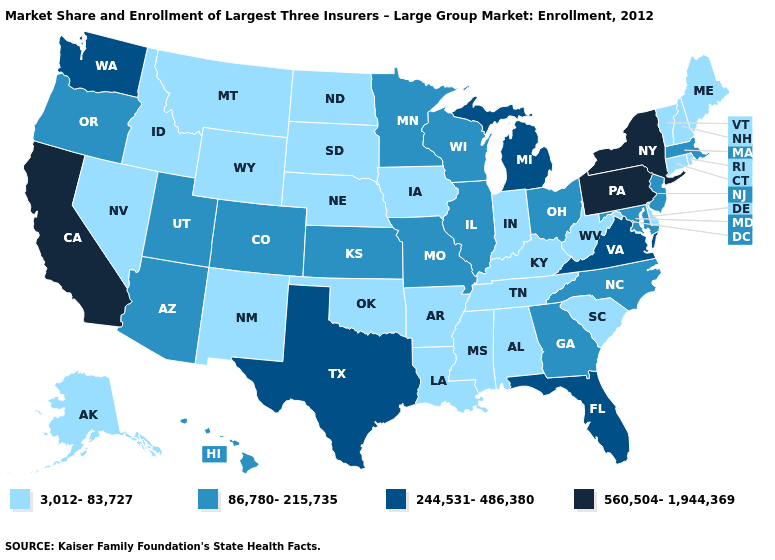What is the highest value in the West ?
Quick response, please. 560,504-1,944,369. Does the first symbol in the legend represent the smallest category?
Be succinct. Yes. Among the states that border Alabama , does Florida have the lowest value?
Keep it brief. No. Does Pennsylvania have the highest value in the USA?
Give a very brief answer. Yes. Which states have the lowest value in the West?
Give a very brief answer. Alaska, Idaho, Montana, Nevada, New Mexico, Wyoming. What is the highest value in the USA?
Keep it brief. 560,504-1,944,369. Name the states that have a value in the range 3,012-83,727?
Concise answer only. Alabama, Alaska, Arkansas, Connecticut, Delaware, Idaho, Indiana, Iowa, Kentucky, Louisiana, Maine, Mississippi, Montana, Nebraska, Nevada, New Hampshire, New Mexico, North Dakota, Oklahoma, Rhode Island, South Carolina, South Dakota, Tennessee, Vermont, West Virginia, Wyoming. Among the states that border Nevada , does Utah have the lowest value?
Quick response, please. No. Does Ohio have the lowest value in the USA?
Concise answer only. No. What is the value of Michigan?
Answer briefly. 244,531-486,380. Among the states that border New Jersey , does Delaware have the highest value?
Concise answer only. No. What is the highest value in the West ?
Keep it brief. 560,504-1,944,369. Does Pennsylvania have the highest value in the USA?
Be succinct. Yes. What is the value of New Jersey?
Be succinct. 86,780-215,735. Does Vermont have the highest value in the USA?
Be succinct. No. 